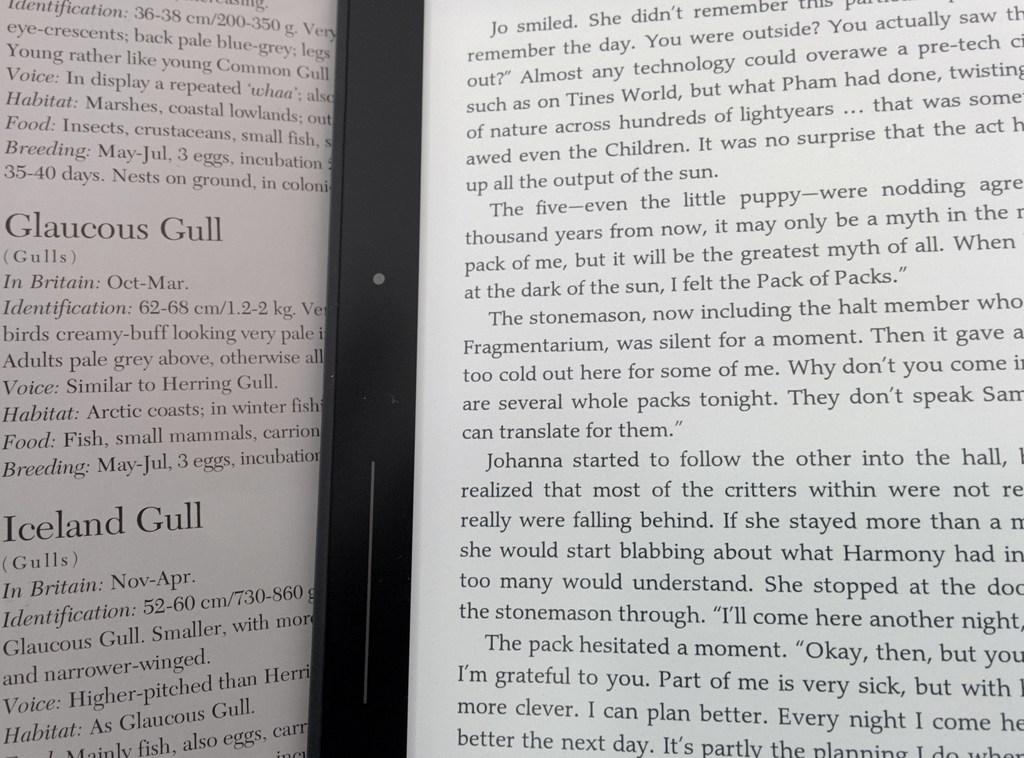Is this book about a pack of animals?
Make the answer very short. Yes. Does it talk about the iceland gull?
Give a very brief answer. Yes. 